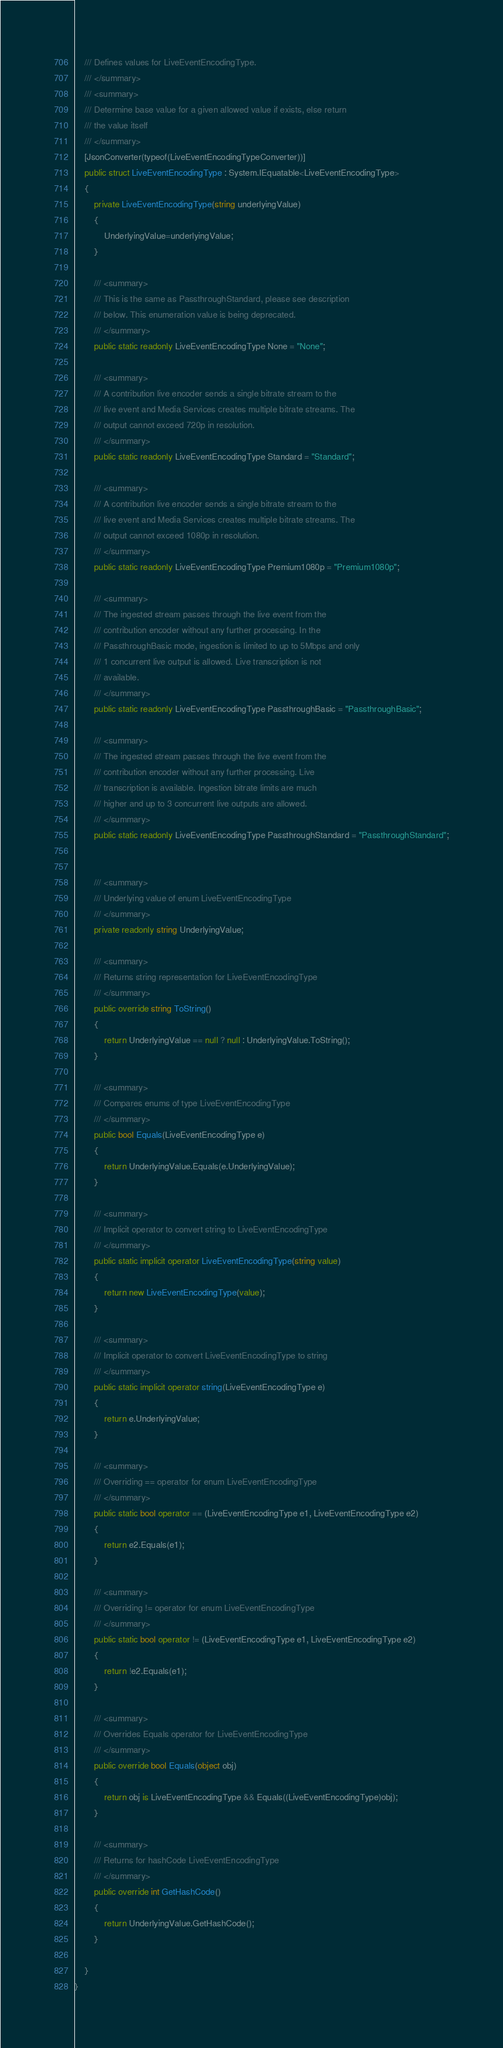<code> <loc_0><loc_0><loc_500><loc_500><_C#_>    /// Defines values for LiveEventEncodingType.
    /// </summary>
    /// <summary>
    /// Determine base value for a given allowed value if exists, else return
    /// the value itself
    /// </summary>
    [JsonConverter(typeof(LiveEventEncodingTypeConverter))]
    public struct LiveEventEncodingType : System.IEquatable<LiveEventEncodingType>
    {
        private LiveEventEncodingType(string underlyingValue)
        {
            UnderlyingValue=underlyingValue;
        }

        /// <summary>
        /// This is the same as PassthroughStandard, please see description
        /// below. This enumeration value is being deprecated.
        /// </summary>
        public static readonly LiveEventEncodingType None = "None";

        /// <summary>
        /// A contribution live encoder sends a single bitrate stream to the
        /// live event and Media Services creates multiple bitrate streams. The
        /// output cannot exceed 720p in resolution.
        /// </summary>
        public static readonly LiveEventEncodingType Standard = "Standard";

        /// <summary>
        /// A contribution live encoder sends a single bitrate stream to the
        /// live event and Media Services creates multiple bitrate streams. The
        /// output cannot exceed 1080p in resolution.
        /// </summary>
        public static readonly LiveEventEncodingType Premium1080p = "Premium1080p";

        /// <summary>
        /// The ingested stream passes through the live event from the
        /// contribution encoder without any further processing. In the
        /// PassthroughBasic mode, ingestion is limited to up to 5Mbps and only
        /// 1 concurrent live output is allowed. Live transcription is not
        /// available.
        /// </summary>
        public static readonly LiveEventEncodingType PassthroughBasic = "PassthroughBasic";

        /// <summary>
        /// The ingested stream passes through the live event from the
        /// contribution encoder without any further processing. Live
        /// transcription is available. Ingestion bitrate limits are much
        /// higher and up to 3 concurrent live outputs are allowed.
        /// </summary>
        public static readonly LiveEventEncodingType PassthroughStandard = "PassthroughStandard";


        /// <summary>
        /// Underlying value of enum LiveEventEncodingType
        /// </summary>
        private readonly string UnderlyingValue;

        /// <summary>
        /// Returns string representation for LiveEventEncodingType
        /// </summary>
        public override string ToString()
        {
            return UnderlyingValue == null ? null : UnderlyingValue.ToString();
        }

        /// <summary>
        /// Compares enums of type LiveEventEncodingType
        /// </summary>
        public bool Equals(LiveEventEncodingType e)
        {
            return UnderlyingValue.Equals(e.UnderlyingValue);
        }

        /// <summary>
        /// Implicit operator to convert string to LiveEventEncodingType
        /// </summary>
        public static implicit operator LiveEventEncodingType(string value)
        {
            return new LiveEventEncodingType(value);
        }

        /// <summary>
        /// Implicit operator to convert LiveEventEncodingType to string
        /// </summary>
        public static implicit operator string(LiveEventEncodingType e)
        {
            return e.UnderlyingValue;
        }

        /// <summary>
        /// Overriding == operator for enum LiveEventEncodingType
        /// </summary>
        public static bool operator == (LiveEventEncodingType e1, LiveEventEncodingType e2)
        {
            return e2.Equals(e1);
        }

        /// <summary>
        /// Overriding != operator for enum LiveEventEncodingType
        /// </summary>
        public static bool operator != (LiveEventEncodingType e1, LiveEventEncodingType e2)
        {
            return !e2.Equals(e1);
        }

        /// <summary>
        /// Overrides Equals operator for LiveEventEncodingType
        /// </summary>
        public override bool Equals(object obj)
        {
            return obj is LiveEventEncodingType && Equals((LiveEventEncodingType)obj);
        }

        /// <summary>
        /// Returns for hashCode LiveEventEncodingType
        /// </summary>
        public override int GetHashCode()
        {
            return UnderlyingValue.GetHashCode();
        }

    }
}
</code> 